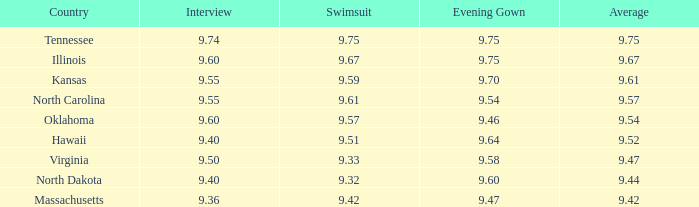Which country had the swimsuit score 9.67? Illinois. 